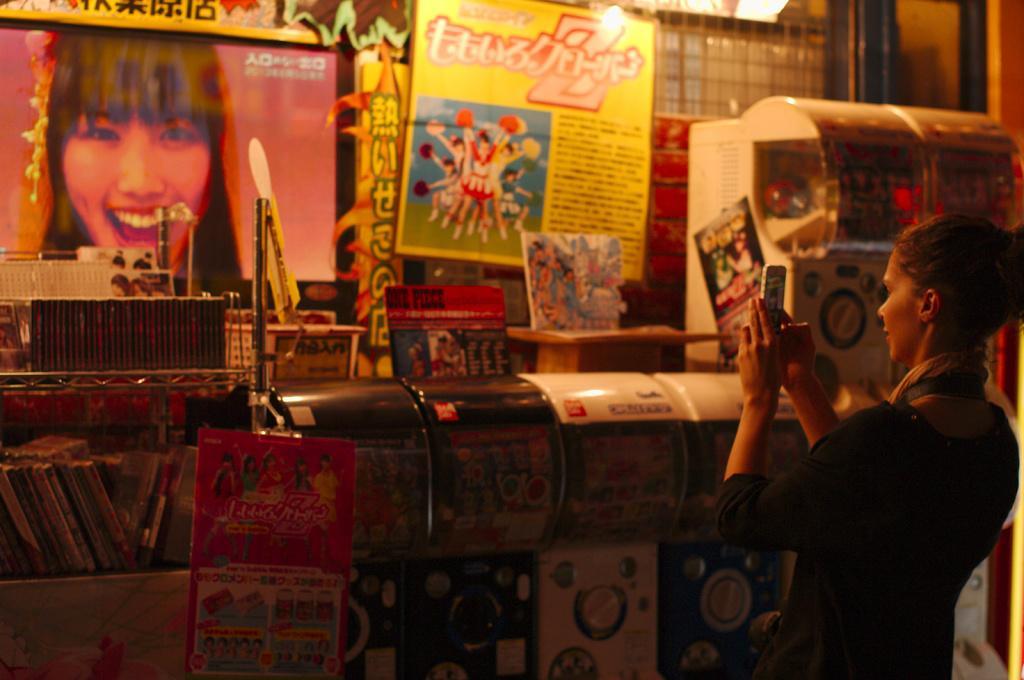Can you describe this image briefly? In this image I can see a person standing and holding a mobile. There are books, machines, posters and there are some other objects. 